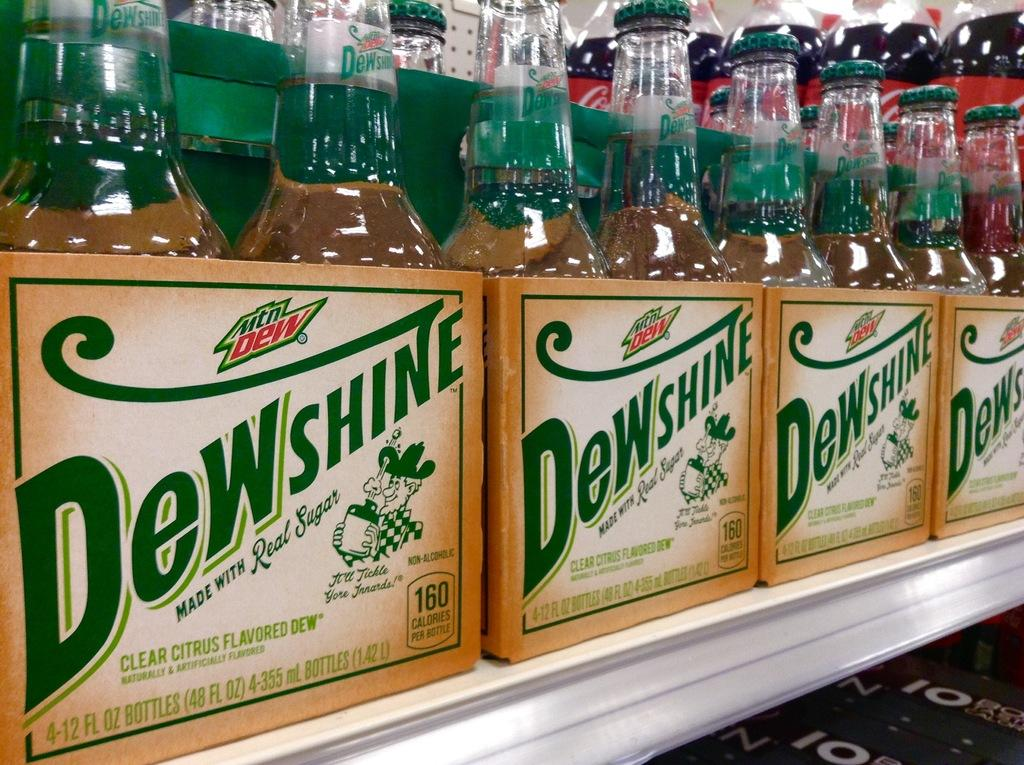What type of table is in the image? There is a white table in the image. What is on top of the table? There are boxes of glass bottles on the table. What is written on the boxes? The boxes have "Dewshine" written on them. What else can be seen behind the boxes? There are other plastic bottles visible behind the boxes. What type of berry is growing on the table in the image? There are no berries present in the image; the table has boxes of glass bottles and plastic bottles on it. 